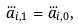Convert formula to latex. <formula><loc_0><loc_0><loc_500><loc_500>\dddot { a } _ { i , 1 } = \dddot { a } _ { i , 0 } ,</formula> 